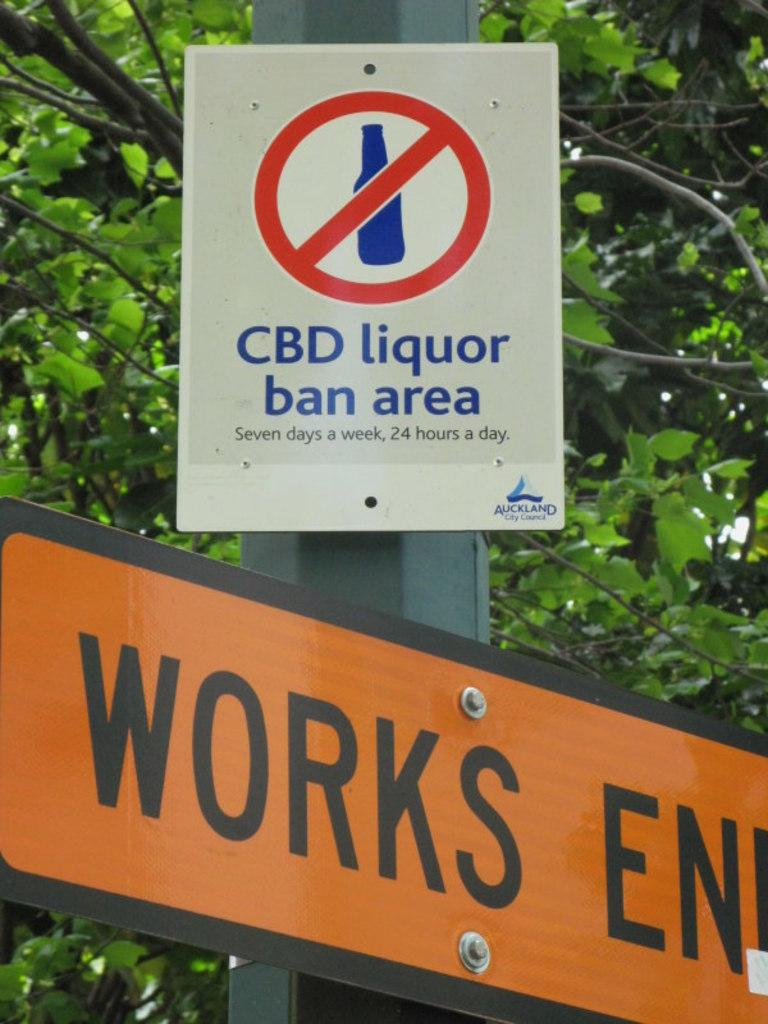<image>
Give a short and clear explanation of the subsequent image. A sign says CBD liquor ban area and is above an orange sign that says Works. 